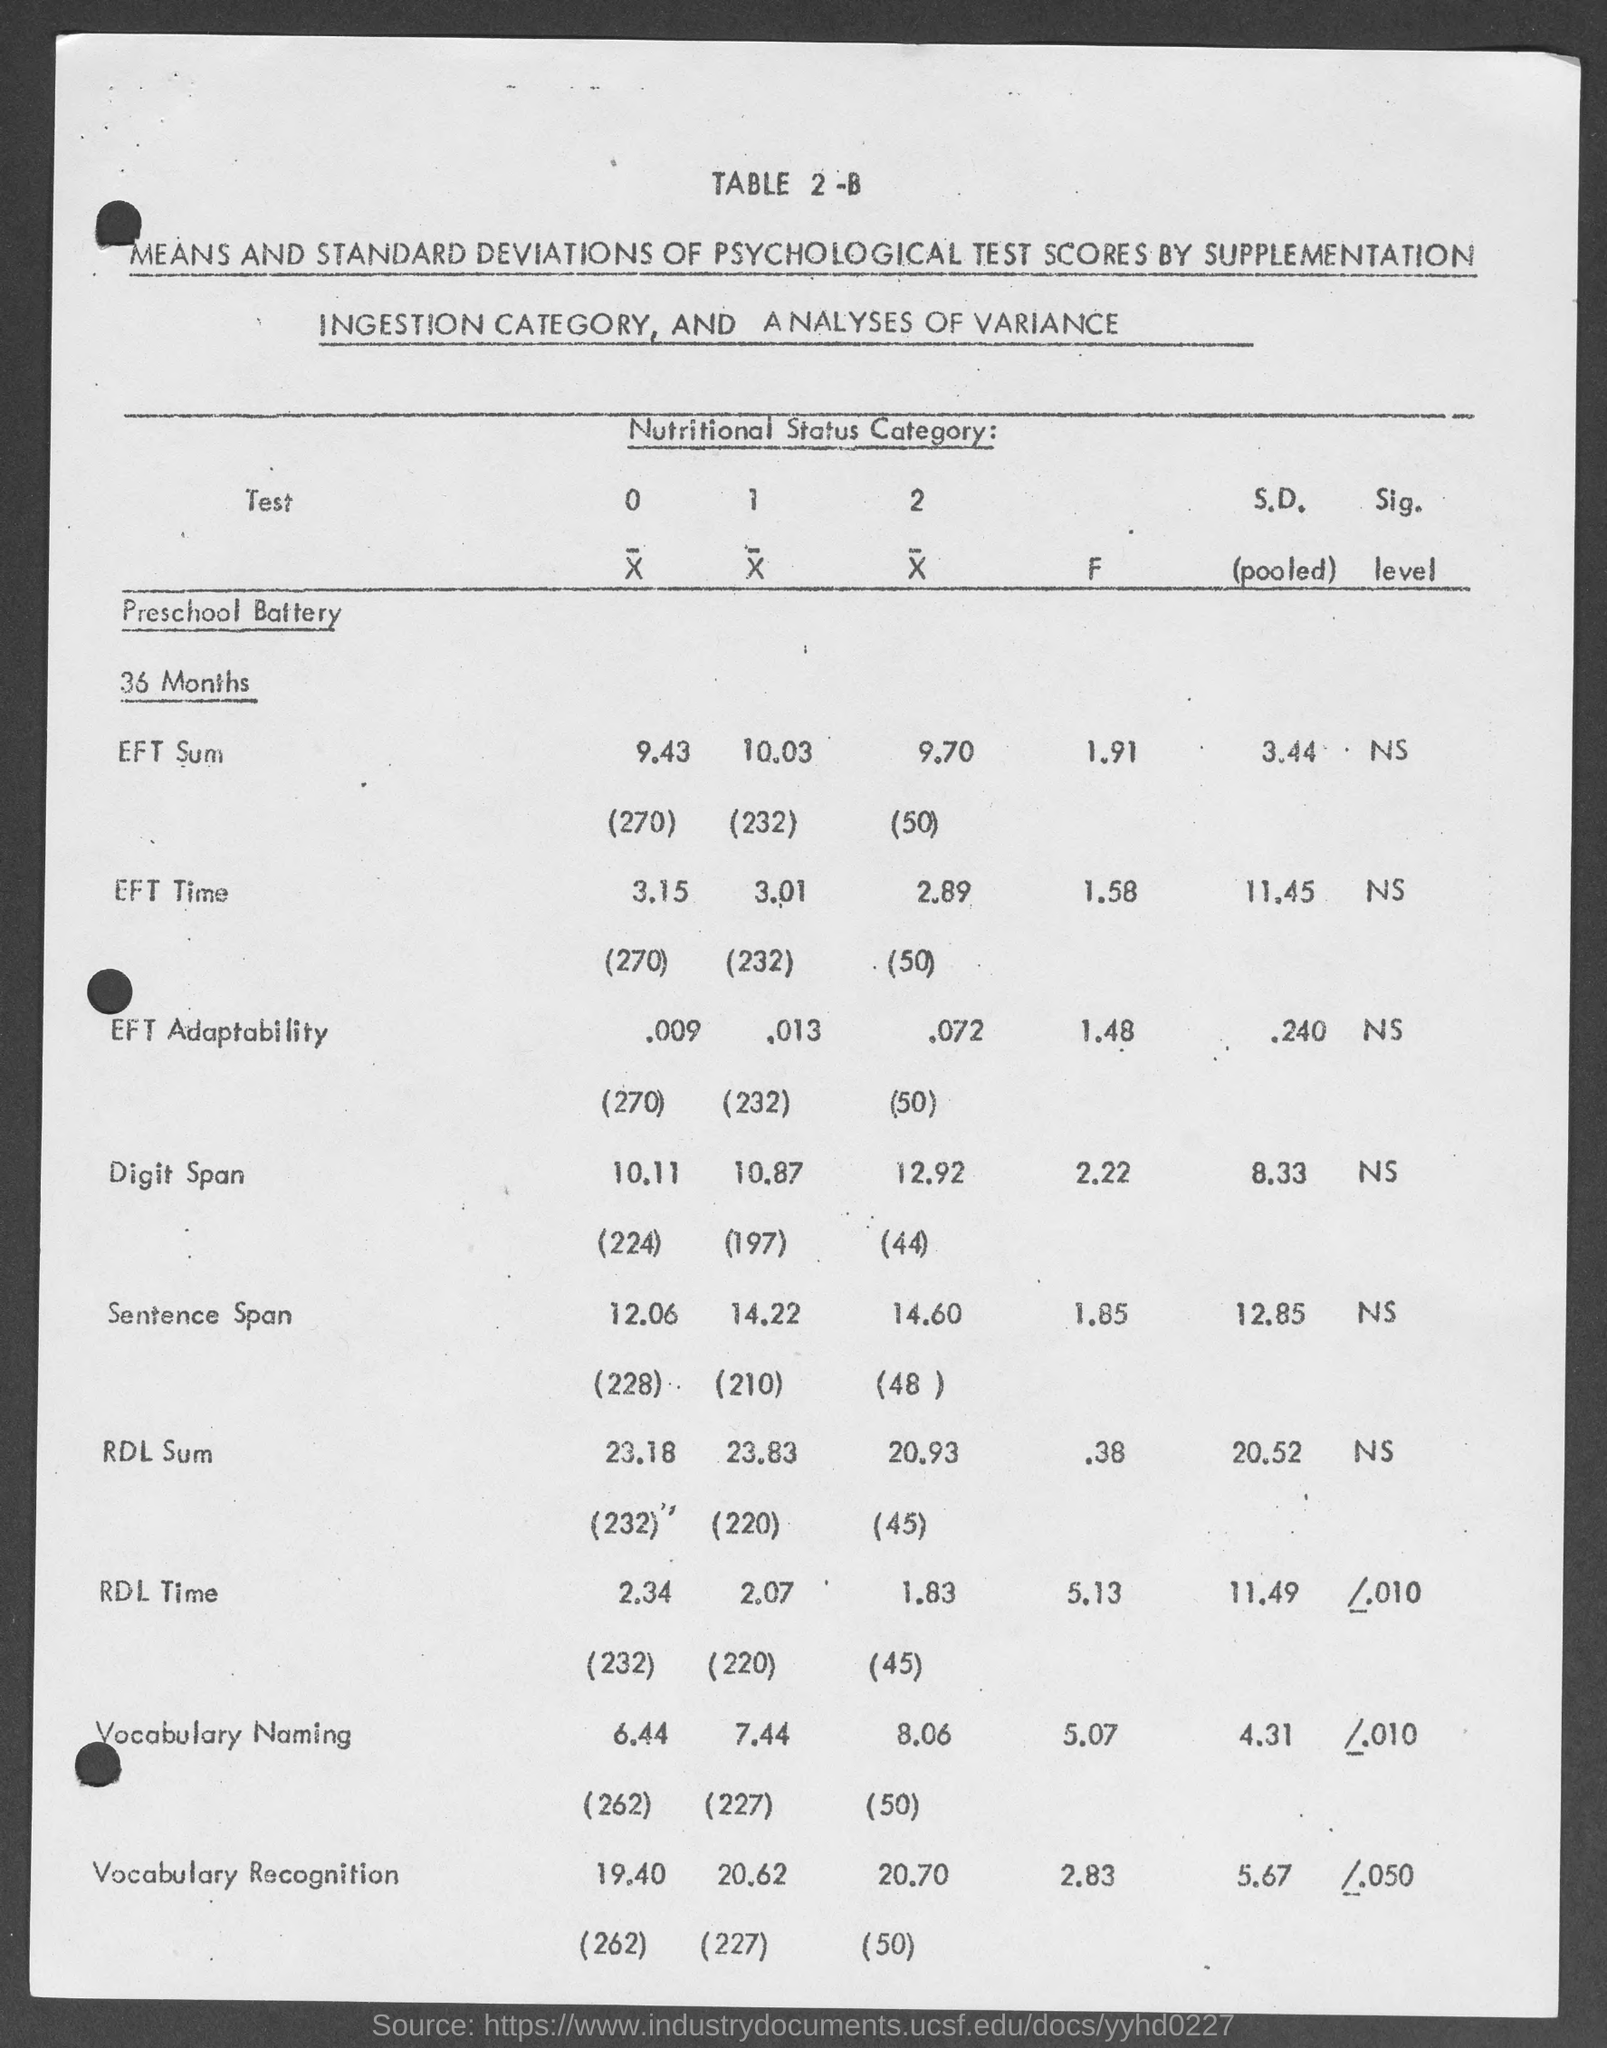Highlight a few significant elements in this photo. I declare that the category is about NUTRITIONAL STATUS. There are 36 months in total. The question "What is the table number?" is asking for information about a specific table. The table number is 2-B. 